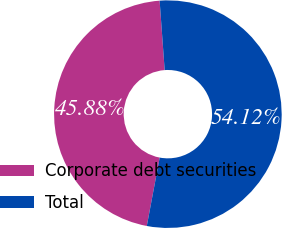Convert chart. <chart><loc_0><loc_0><loc_500><loc_500><pie_chart><fcel>Corporate debt securities<fcel>Total<nl><fcel>45.88%<fcel>54.12%<nl></chart> 